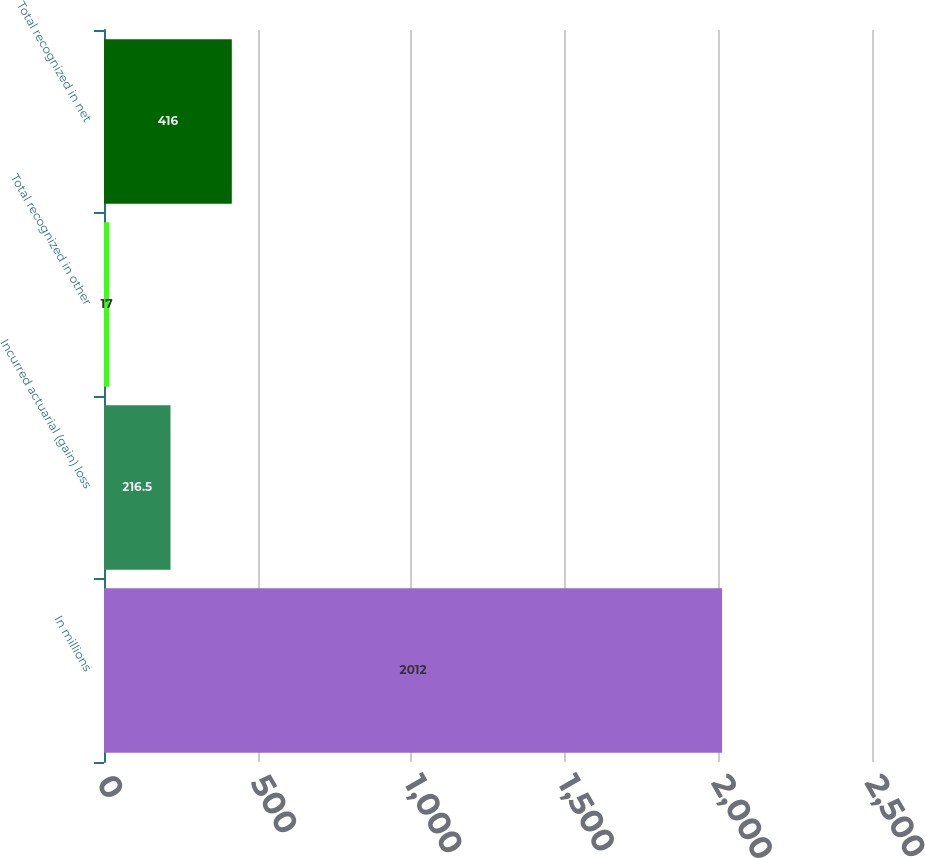<chart> <loc_0><loc_0><loc_500><loc_500><bar_chart><fcel>In millions<fcel>Incurred actuarial (gain) loss<fcel>Total recognized in other<fcel>Total recognized in net<nl><fcel>2012<fcel>216.5<fcel>17<fcel>416<nl></chart> 